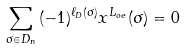Convert formula to latex. <formula><loc_0><loc_0><loc_500><loc_500>\sum _ { \sigma \in D _ { n } } { ( - 1 ) ^ { \ell _ { D } ( \sigma ) } x ^ { L _ { o e } } ( \sigma ) } = 0</formula> 